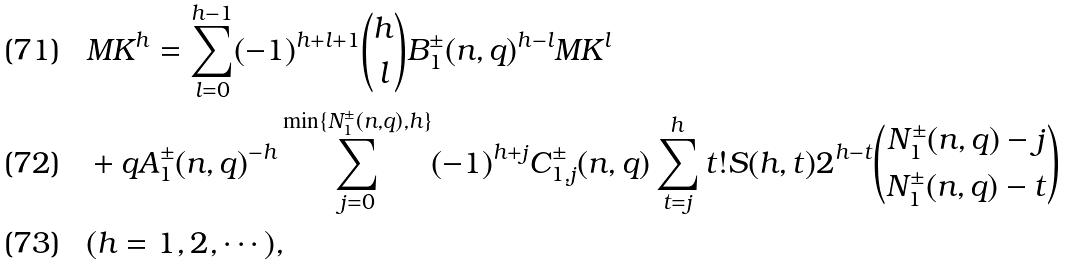<formula> <loc_0><loc_0><loc_500><loc_500>& M K ^ { h } = \sum _ { l = 0 } ^ { h - 1 } ( - 1 ) ^ { h + l + 1 } \binom { h } { l } B _ { 1 } ^ { \pm } ( n , q ) ^ { h - l } M K ^ { l } \\ & + q A _ { 1 } ^ { \pm } ( n , q ) ^ { - h } \sum _ { j = 0 } ^ { \min \{ N _ { 1 } ^ { \pm } ( n , q ) , h \} } ( - 1 ) ^ { h + j } C _ { 1 , j } ^ { \pm } ( n , q ) \sum _ { t = j } ^ { h } t ! S ( h , t ) 2 ^ { h - t } \binom { N _ { 1 } ^ { \pm } ( n , q ) - j } { N _ { 1 } ^ { \pm } ( n , q ) - t } \\ & ( h = 1 , 2 , \cdots ) ,</formula> 